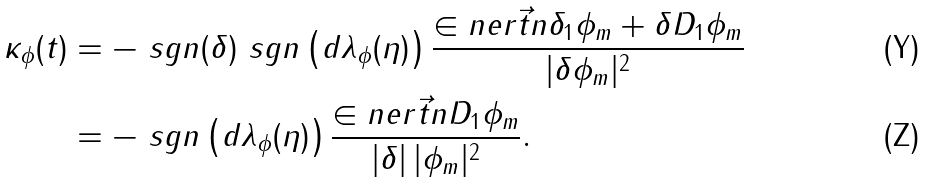Convert formula to latex. <formula><loc_0><loc_0><loc_500><loc_500>\kappa _ { \phi } ( t ) & = - \ s g n ( \delta ) \ s g n \left ( d \lambda _ { \phi } ( \eta ) \right ) \frac { \in n e r { \vec { t } { n } } { \delta _ { 1 } \phi _ { m } + \delta D _ { 1 } \phi _ { m } } } { | \delta \phi _ { m } | ^ { 2 } } \\ & = - \ s g n \left ( d \lambda _ { \phi } ( \eta ) \right ) \frac { \in n e r { \vec { t } { n } } { D _ { 1 } \phi _ { m } } } { | \delta | \, | \phi _ { m } | ^ { 2 } } .</formula> 